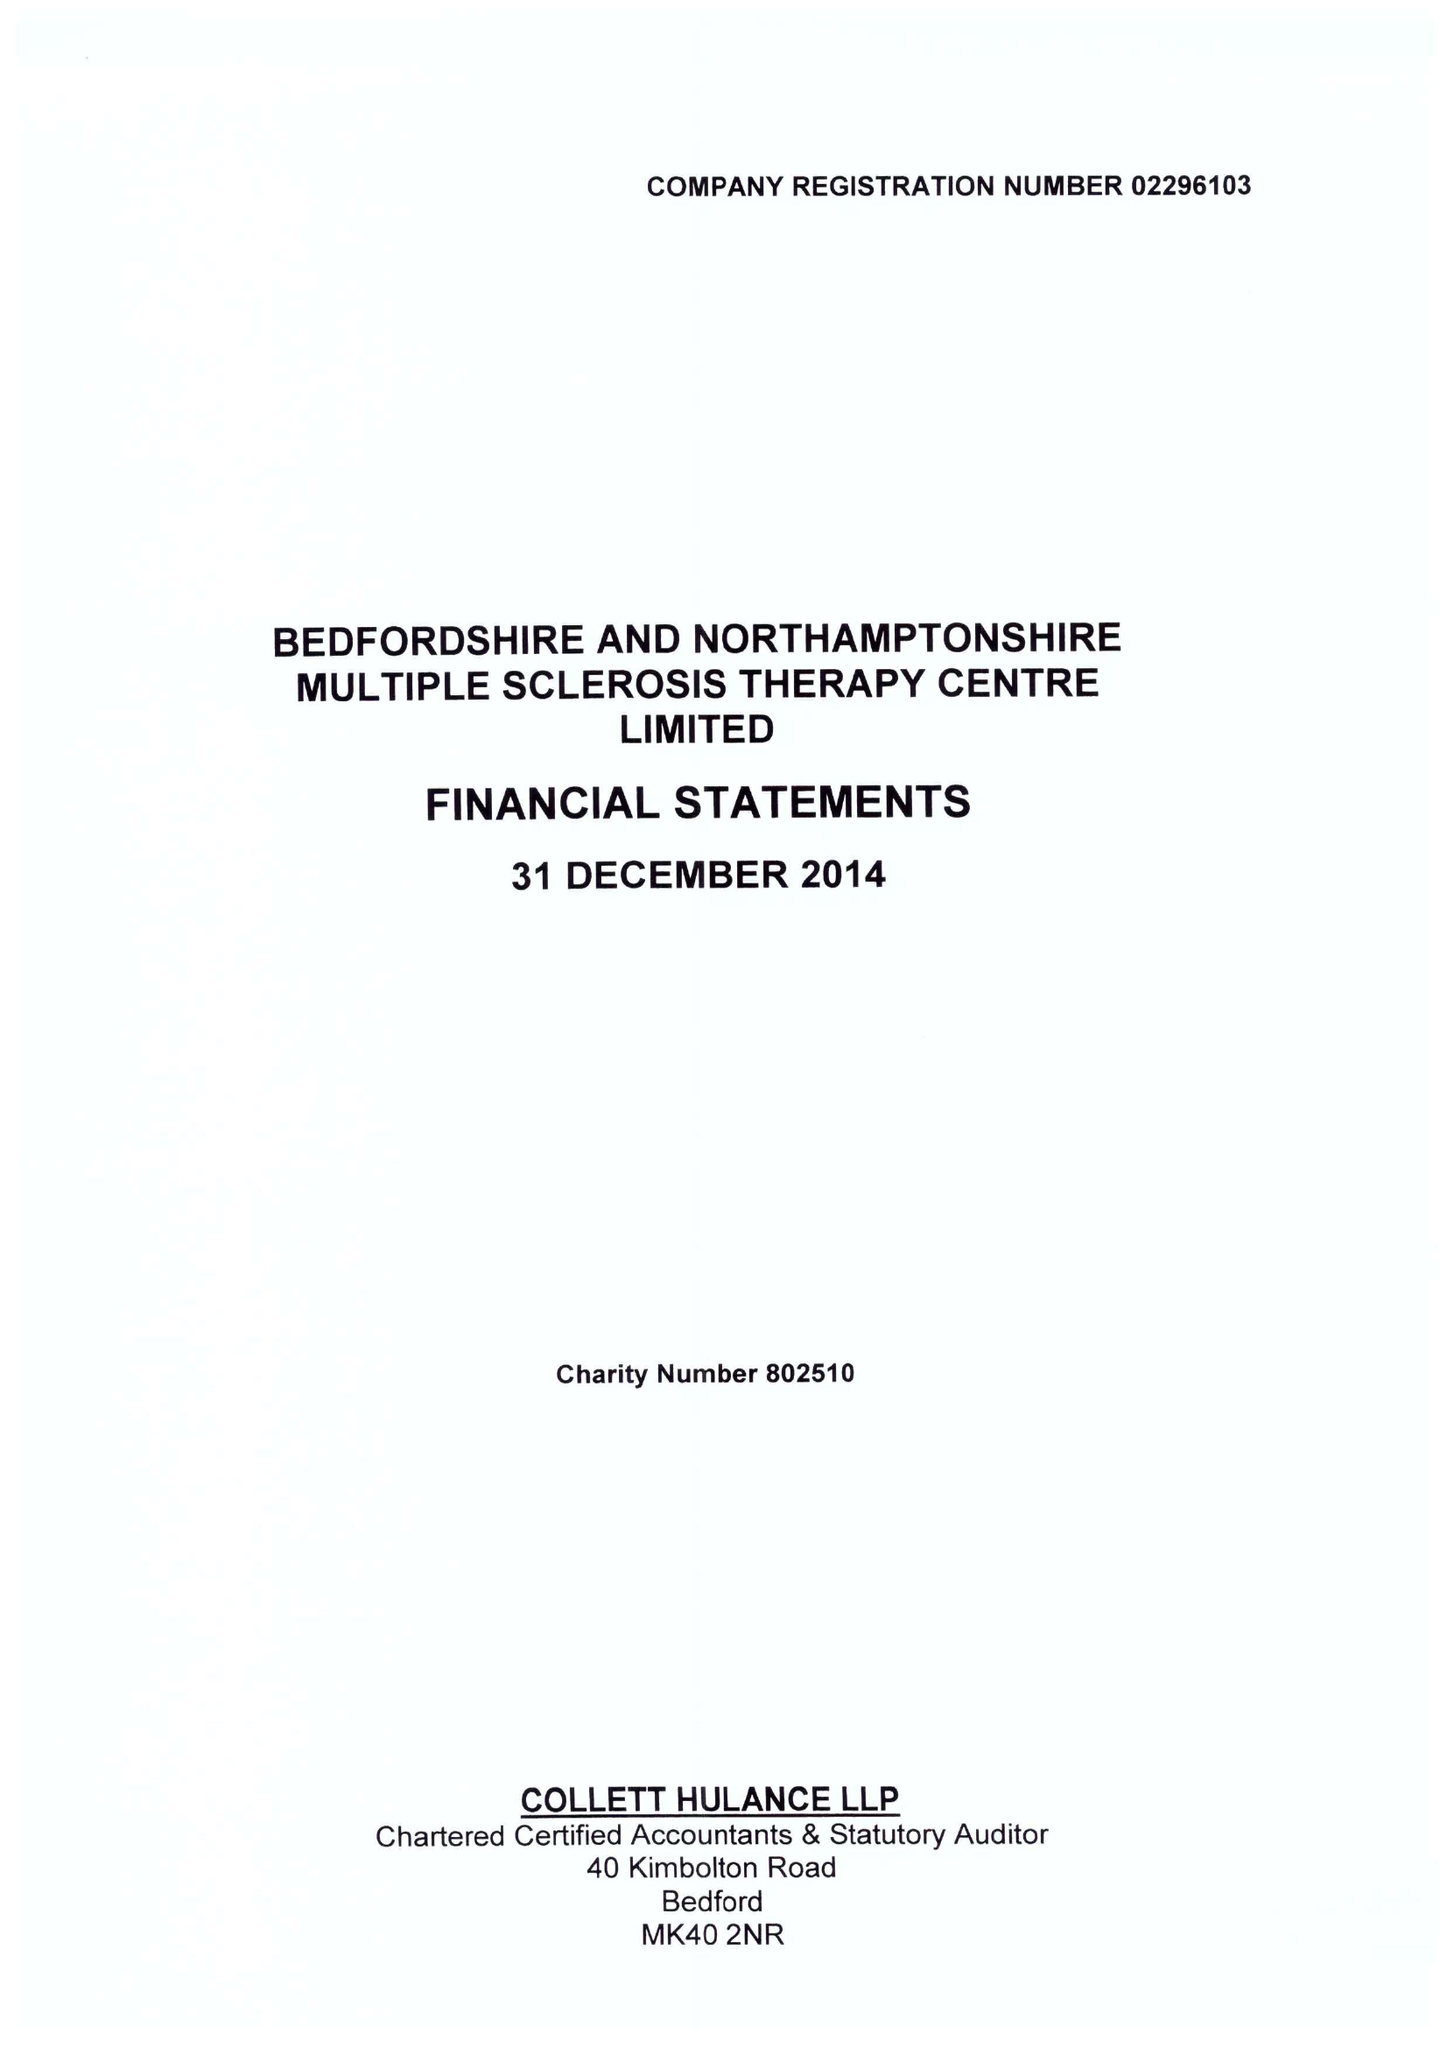What is the value for the report_date?
Answer the question using a single word or phrase. 2014-12-31 